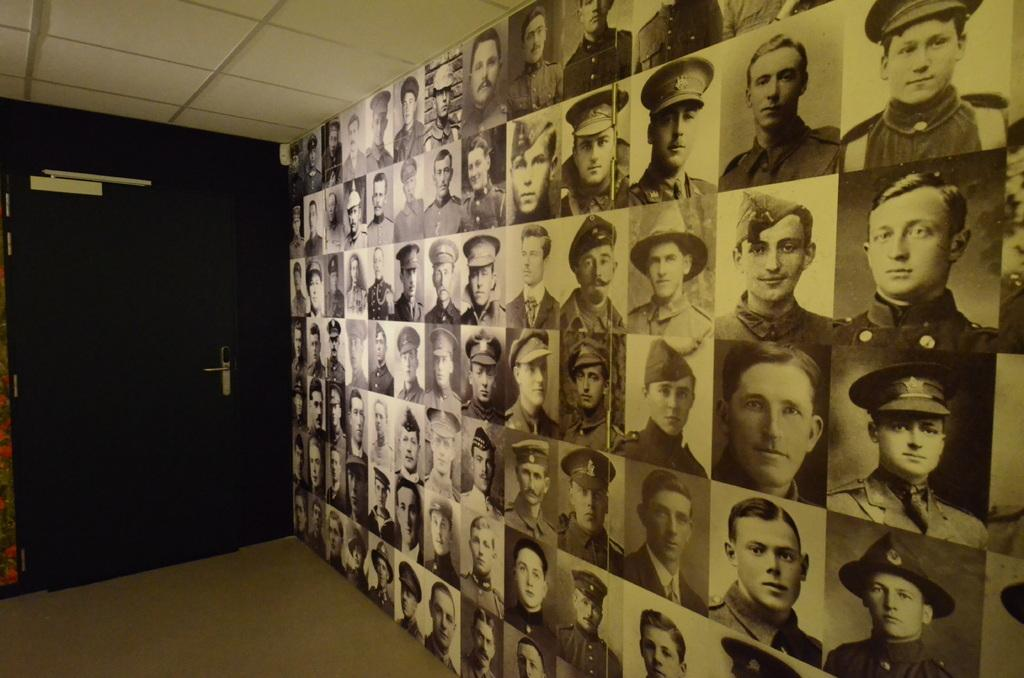What type of view is shown in the image? The image is an inside view. What can be seen on the right side of the image? There is a board with images of people on the right side. What is located on the left side of the image? There is a door on the left side. What part of the room is visible at the bottom of the image? The floor is visible at the bottom of the image. What type of stone is being rolled across the floor in the image? There is no stone or rolling action present in the image. 